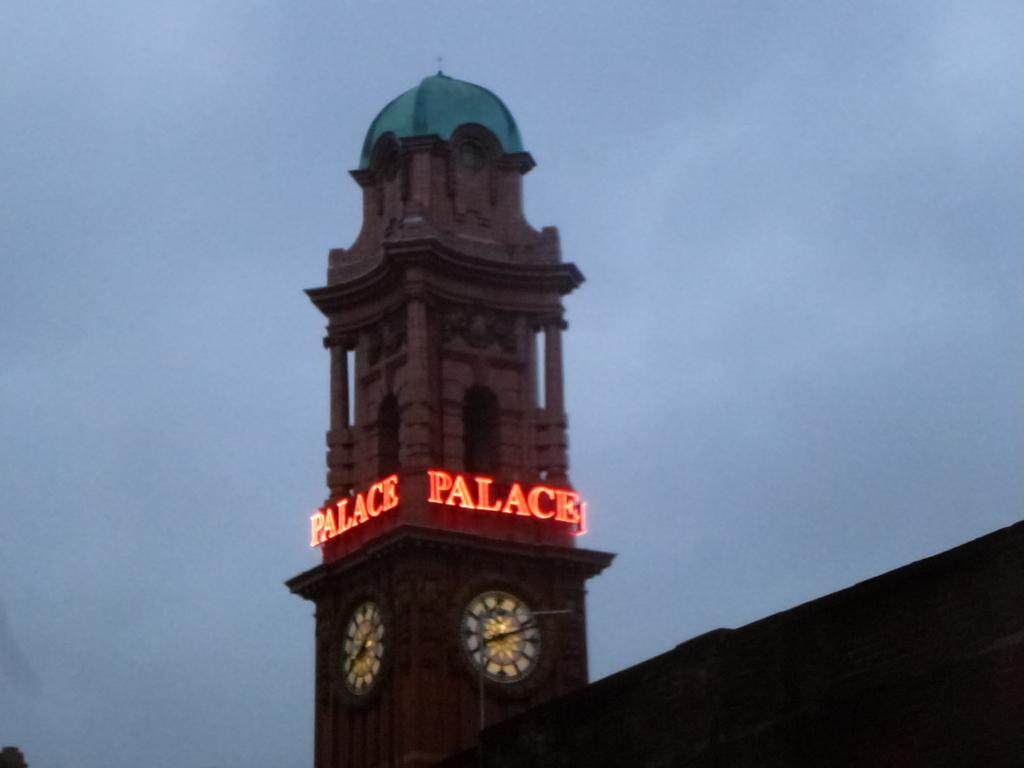Provide a one-sentence caption for the provided image. Tall building with the words Palace on it. 